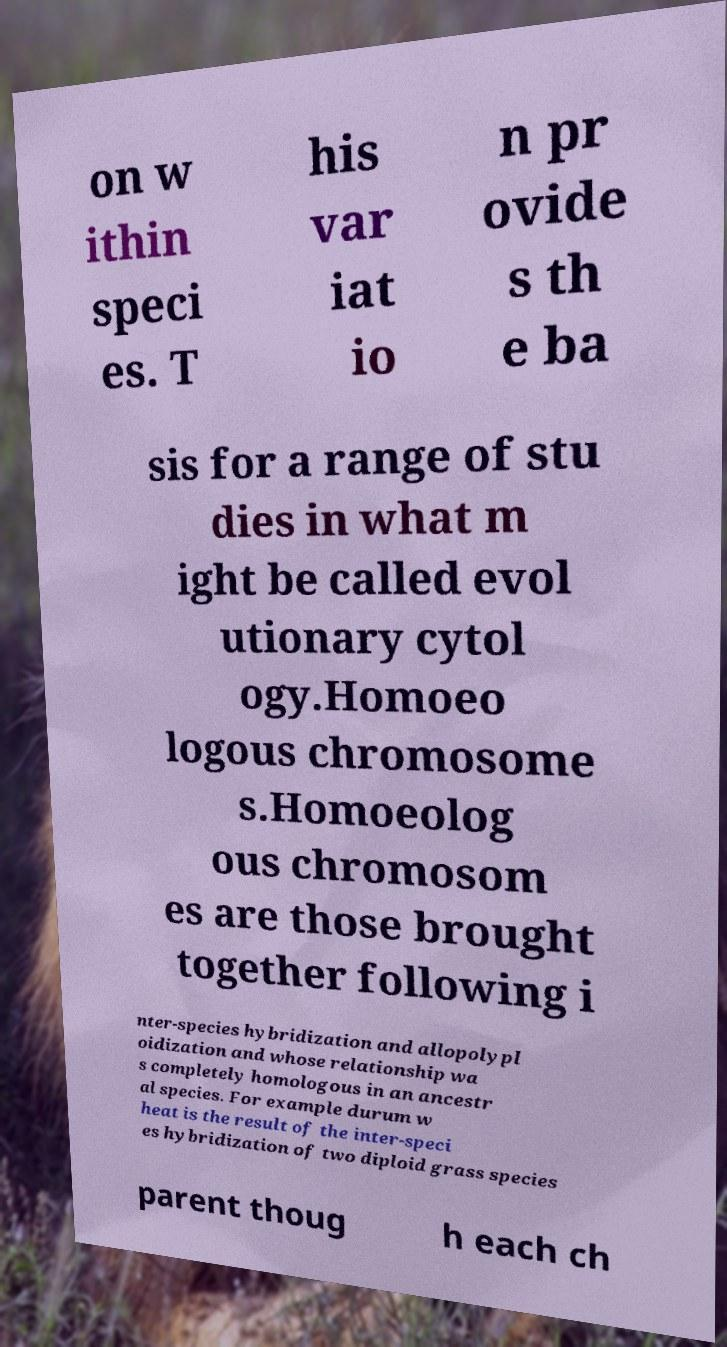What messages or text are displayed in this image? I need them in a readable, typed format. on w ithin speci es. T his var iat io n pr ovide s th e ba sis for a range of stu dies in what m ight be called evol utionary cytol ogy.Homoeo logous chromosome s.Homoeolog ous chromosom es are those brought together following i nter-species hybridization and allopolypl oidization and whose relationship wa s completely homologous in an ancestr al species. For example durum w heat is the result of the inter-speci es hybridization of two diploid grass species parent thoug h each ch 